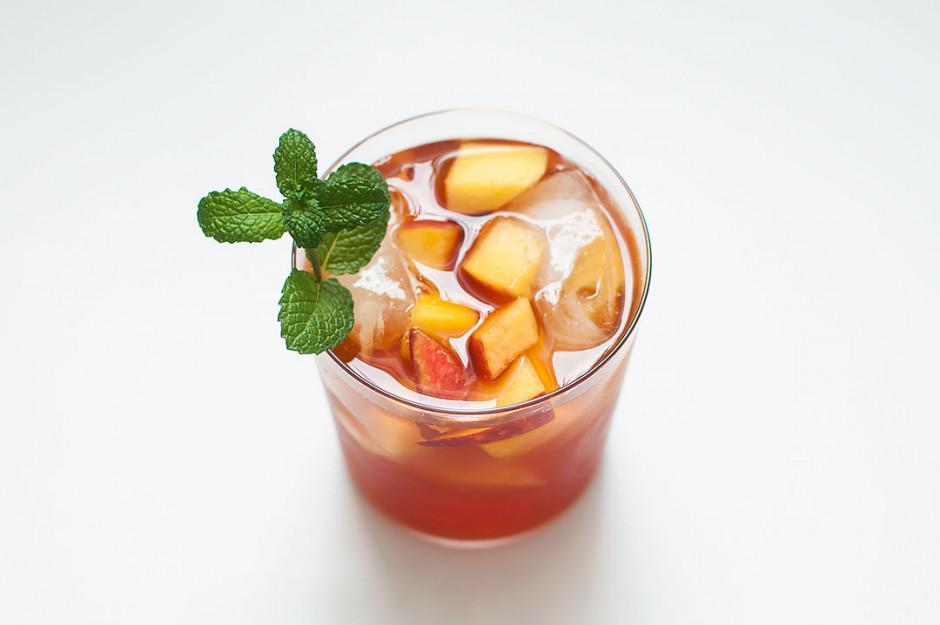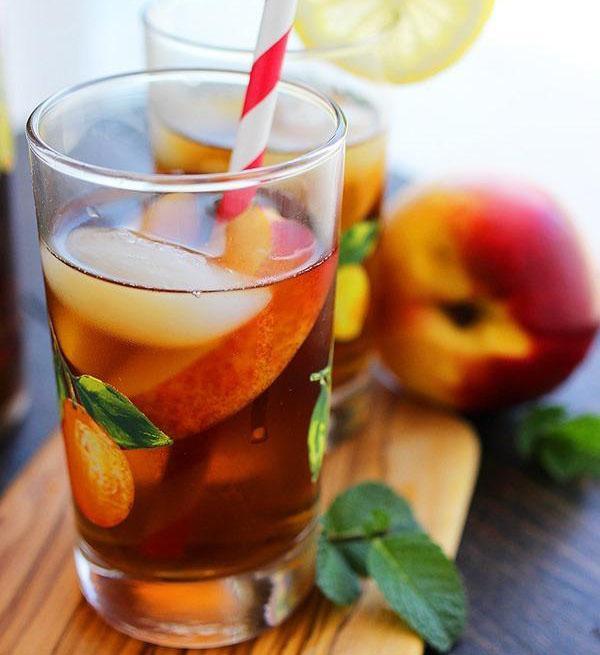The first image is the image on the left, the second image is the image on the right. Evaluate the accuracy of this statement regarding the images: "One straw is at least partly red.". Is it true? Answer yes or no. Yes. The first image is the image on the left, the second image is the image on the right. For the images shown, is this caption "The left image features a beverage in a jar-type glass with a handle, and the beverage has a straw in it and a green leaf for garnish." true? Answer yes or no. No. 